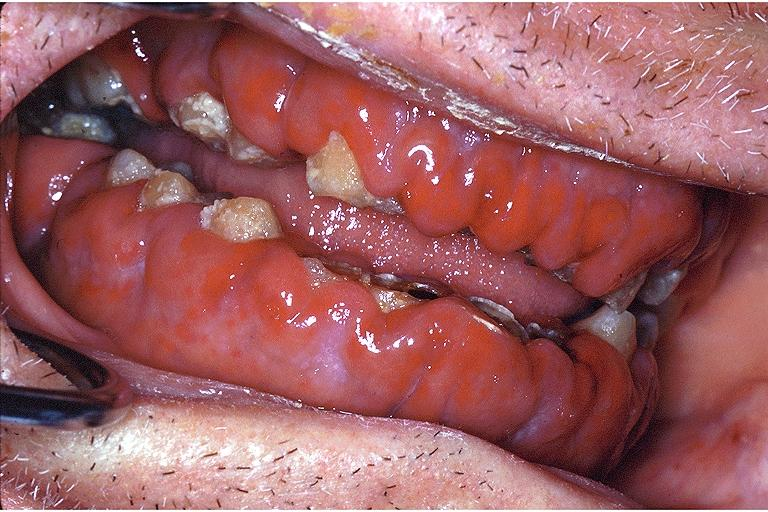what is present?
Answer the question using a single word or phrase. Oral 